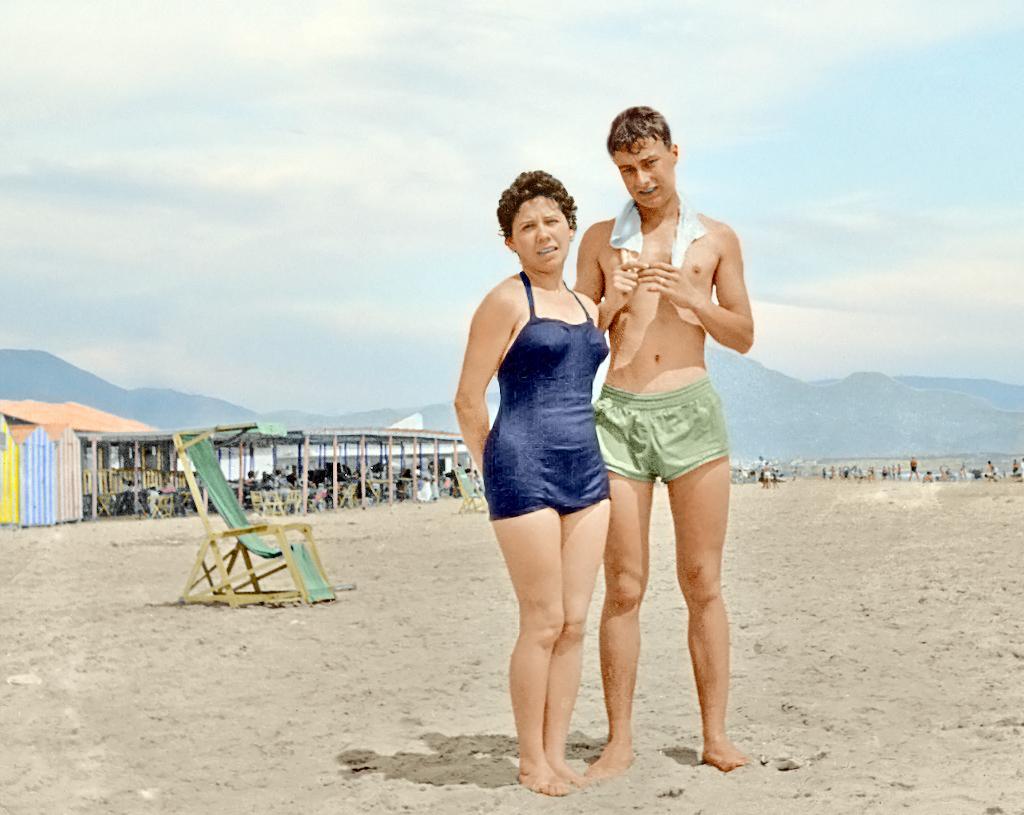Describe this image in one or two sentences. In the image a woman and a man are standing on the sand, behind them there is a chair and on the left side there is a shelter and in the background there are some other people and behind them there are many mountains. 